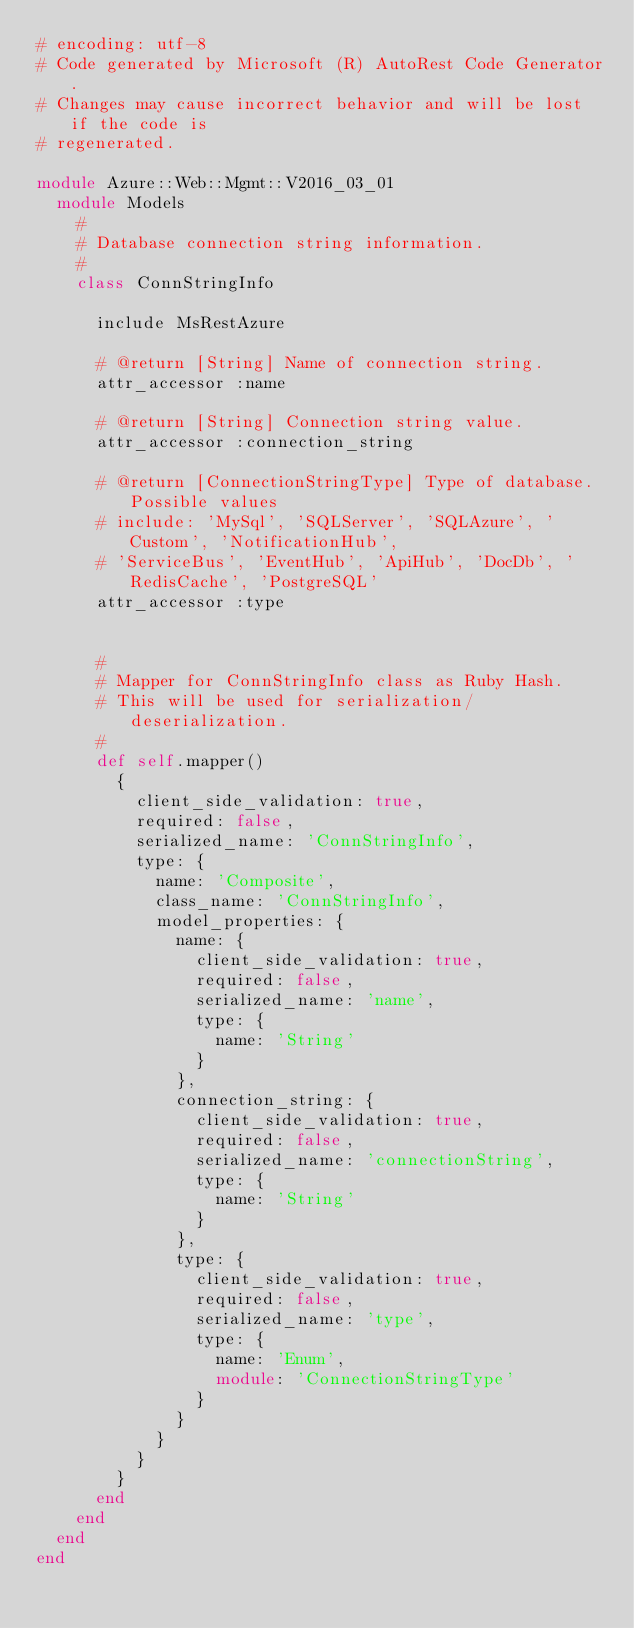<code> <loc_0><loc_0><loc_500><loc_500><_Ruby_># encoding: utf-8
# Code generated by Microsoft (R) AutoRest Code Generator.
# Changes may cause incorrect behavior and will be lost if the code is
# regenerated.

module Azure::Web::Mgmt::V2016_03_01
  module Models
    #
    # Database connection string information.
    #
    class ConnStringInfo

      include MsRestAzure

      # @return [String] Name of connection string.
      attr_accessor :name

      # @return [String] Connection string value.
      attr_accessor :connection_string

      # @return [ConnectionStringType] Type of database. Possible values
      # include: 'MySql', 'SQLServer', 'SQLAzure', 'Custom', 'NotificationHub',
      # 'ServiceBus', 'EventHub', 'ApiHub', 'DocDb', 'RedisCache', 'PostgreSQL'
      attr_accessor :type


      #
      # Mapper for ConnStringInfo class as Ruby Hash.
      # This will be used for serialization/deserialization.
      #
      def self.mapper()
        {
          client_side_validation: true,
          required: false,
          serialized_name: 'ConnStringInfo',
          type: {
            name: 'Composite',
            class_name: 'ConnStringInfo',
            model_properties: {
              name: {
                client_side_validation: true,
                required: false,
                serialized_name: 'name',
                type: {
                  name: 'String'
                }
              },
              connection_string: {
                client_side_validation: true,
                required: false,
                serialized_name: 'connectionString',
                type: {
                  name: 'String'
                }
              },
              type: {
                client_side_validation: true,
                required: false,
                serialized_name: 'type',
                type: {
                  name: 'Enum',
                  module: 'ConnectionStringType'
                }
              }
            }
          }
        }
      end
    end
  end
end
</code> 